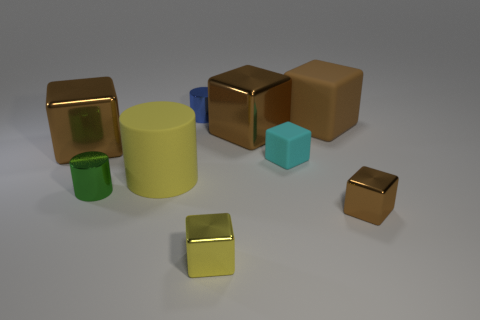Can you tell me the number of geometric shapes in the image and identify them by color? Certainly! There are eight geometric shapes in the image: one green and one brown cube, two golden cubes, a blue cylinder, a small cyan cube, and two small yellow cubes. 